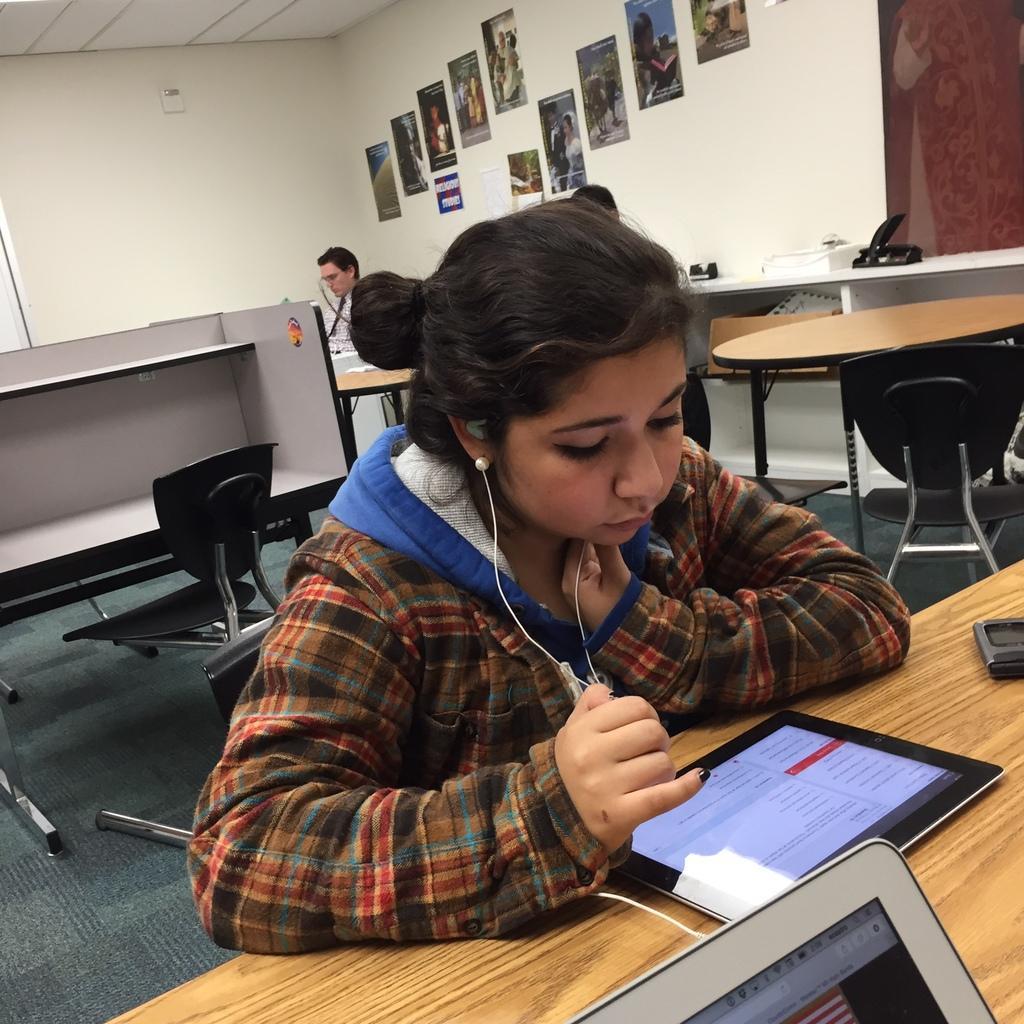How would you summarize this image in a sentence or two? In this image we can see three persons, one of them is wearing a headphone, in front of her, there is a table, on that there is a tablet, a monitor, and a cell phone, there are chairs tables, there are some objects on a table, there are photo frames on the wall. 